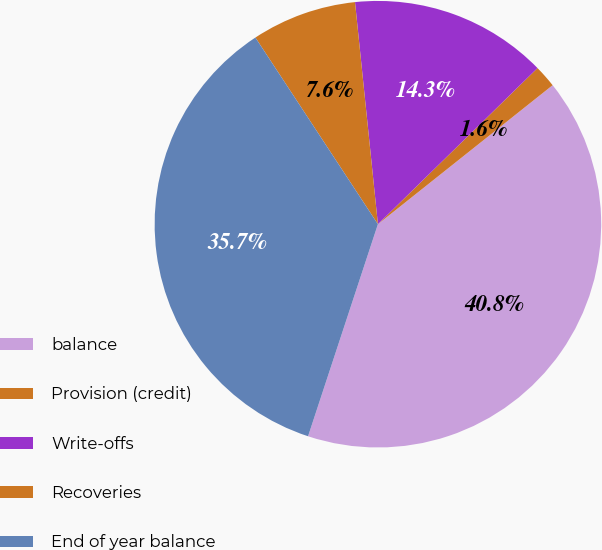<chart> <loc_0><loc_0><loc_500><loc_500><pie_chart><fcel>balance<fcel>Provision (credit)<fcel>Write-offs<fcel>Recoveries<fcel>End of year balance<nl><fcel>40.76%<fcel>1.63%<fcel>14.31%<fcel>7.61%<fcel>35.69%<nl></chart> 